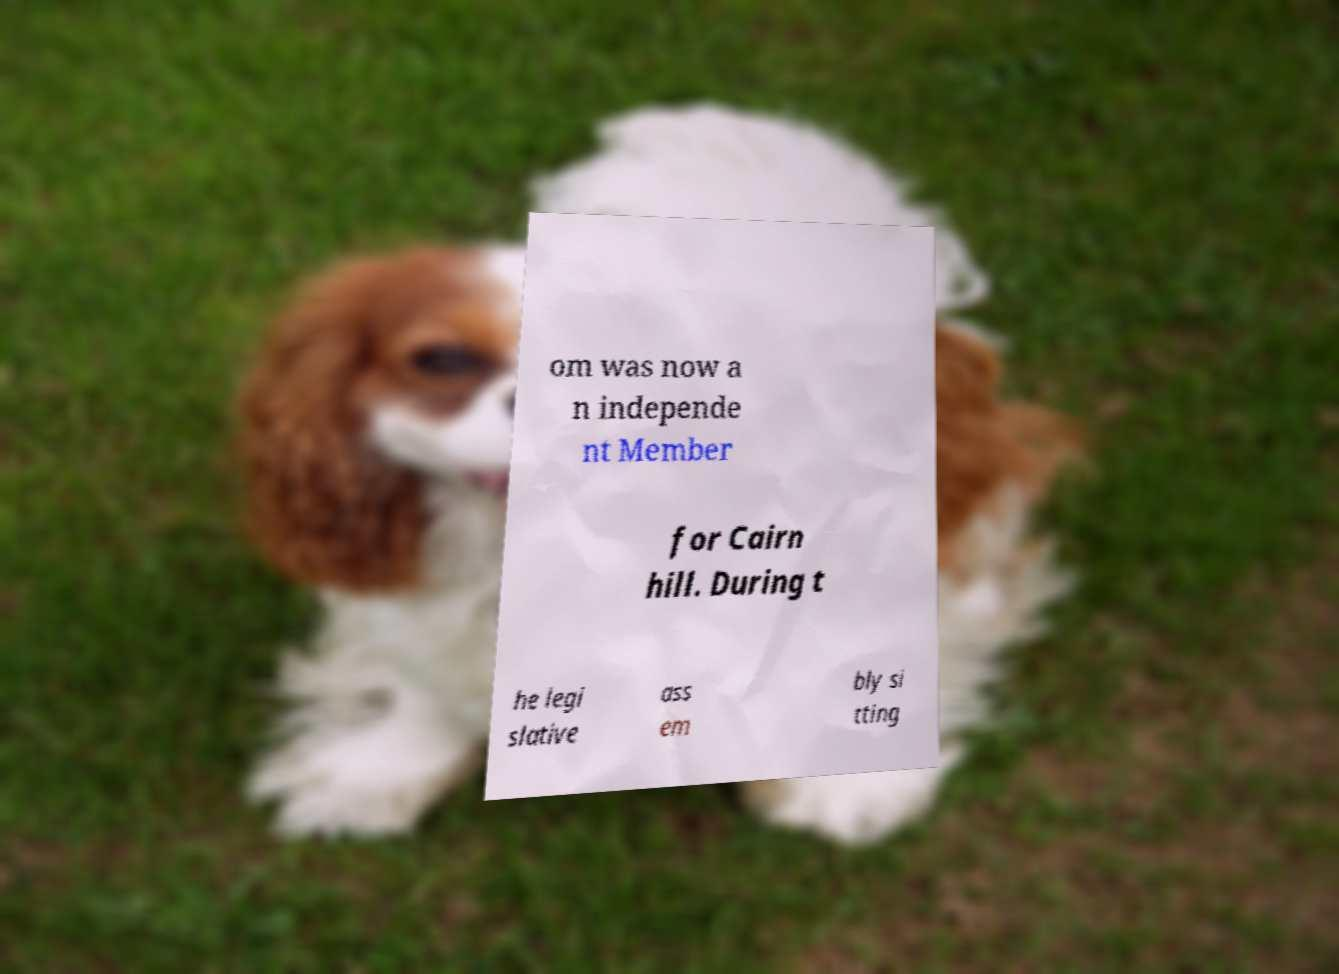Could you assist in decoding the text presented in this image and type it out clearly? om was now a n independe nt Member for Cairn hill. During t he legi slative ass em bly si tting 